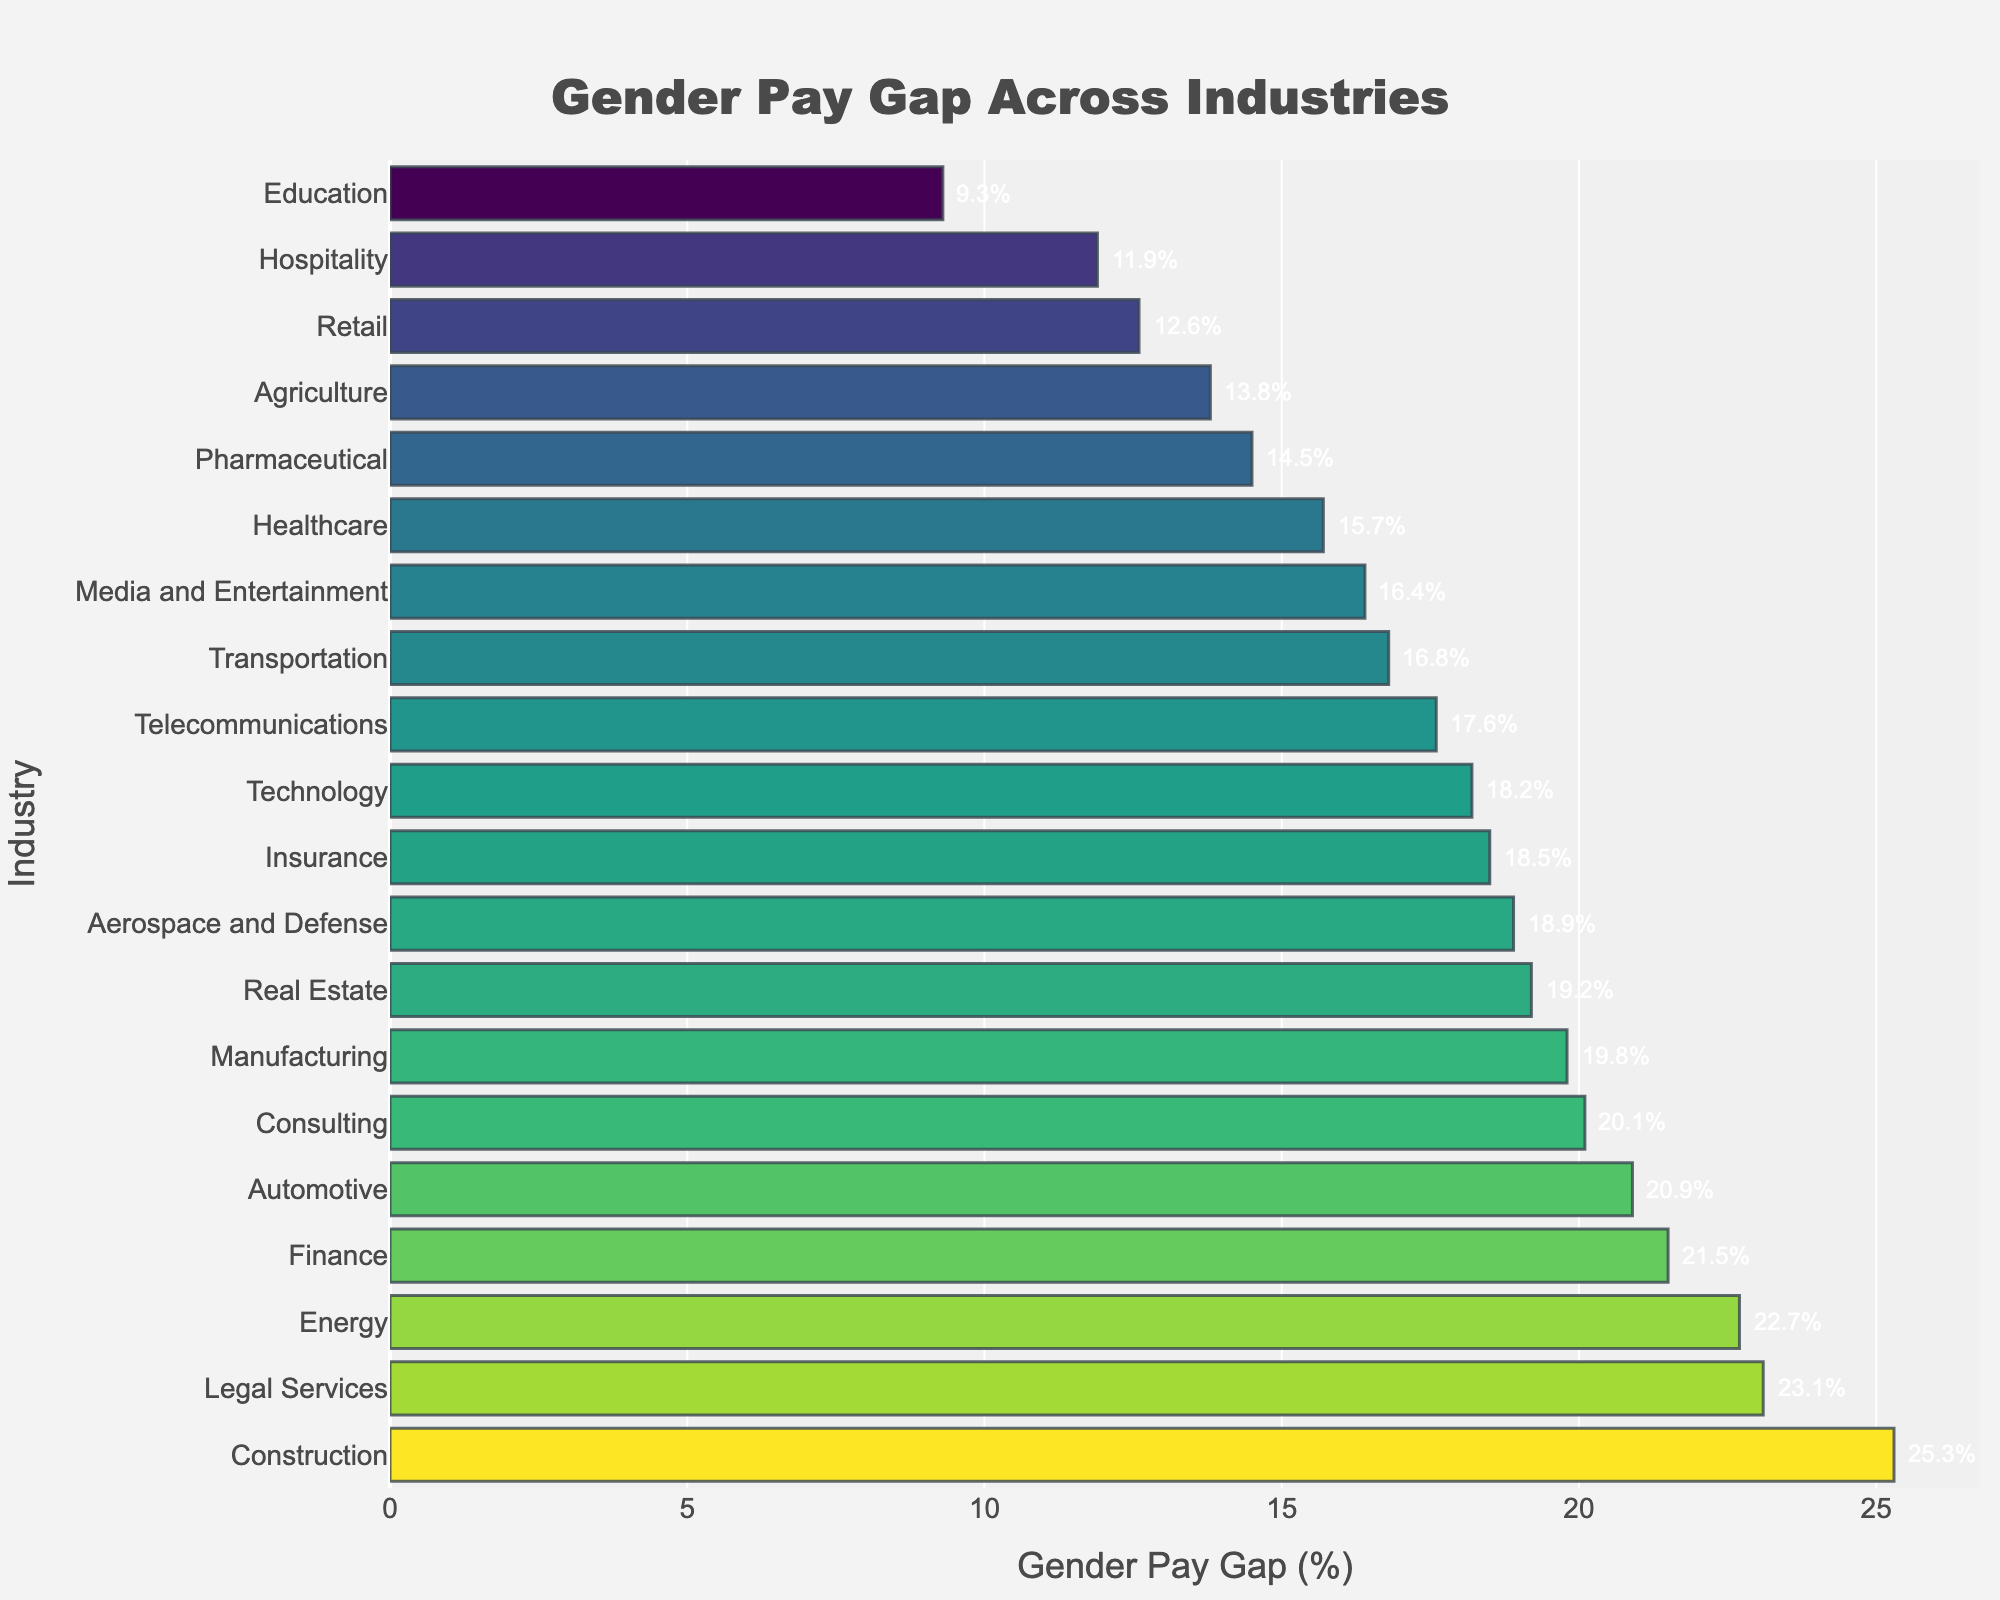Which industry has the highest gender pay gap? The bar with the highest length represents the highest gender pay gap, which is labeled as "Construction" with 25.3%.
Answer: Construction Which two industries have the smallest gender pay gaps, and what are their values? The shortest bars represent the smallest gender pay gaps, which are labeled as "Education" with 9.3% and "Hospitality" with 11.9%.
Answer: Education (9.3%) and Hospitality (11.9%) What is the difference in the gender pay gap between Legal Services and Agriculture? The bar for Legal Services is labeled as 23.1%, and the bar for Agriculture is labeled as 13.8%. The difference is calculated by subtracting 13.8 from 23.1.
Answer: 9.3% Which industry has a higher gender pay gap: Media and Entertainment or Telecommunications, and by how much? The bar for Media and Entertainment shows 16.4%, and the bar for Telecommunications shows 17.6%. Telecommunication has a higher pay gap. The difference is calculated by subtracting 16.4 from 17.6.
Answer: Telecommunications by 1.2% What is the combined gender pay gap for Technology, Finance, and Healthcare? The bars show 18.2% for Technology, 21.5% for Finance, and 15.7% for Healthcare. The combined gap is the sum of these values: 18.2 + 21.5 + 15.7.
Answer: 55.4% How does the gender pay gap in the Pharmaceutical industry compare to that in the Retail industry? The bar for Pharmaceutical shows 14.5%, and the bar for Retail shows 12.6%. The Pharmaceutical industry has a higher gender pay gap.
Answer: Pharmaceutical is higher Which industry has a gender pay gap closest to the average gap of all industries? To determine this, one would need to calculate the average of all provided values and identify the closest bar. The total sum of the percentages is (add all values) and the number of industries is 20. The average is the total sum divided by 20. Compare each bar to this average.
Answer: Detail below Which industry has the largest difference between its gender pay gap and the overall average gap? Calculate the overall average as 17.85% and then find the absolute difference between each value and the average, the largest difference corresponds to the highest absolute value.
Answer: Construction (7.45%) What is the range of gender pay gaps across these industries? The range is calculated by subtracting the smallest value from the largest value. The smallest value is 9.3% in Education, and the largest is 25.3% in Construction. The range is 25.3 - 9.3.
Answer: 16% In which industry do women face almost double the gender pay gap compared to the Education industry? The gender pay gap in Education is 9.3%, and we need to find a gap close to 18.6% (almost double). The closest value is in Telecommunications with 17.6%.
Answer: Telecommunications 